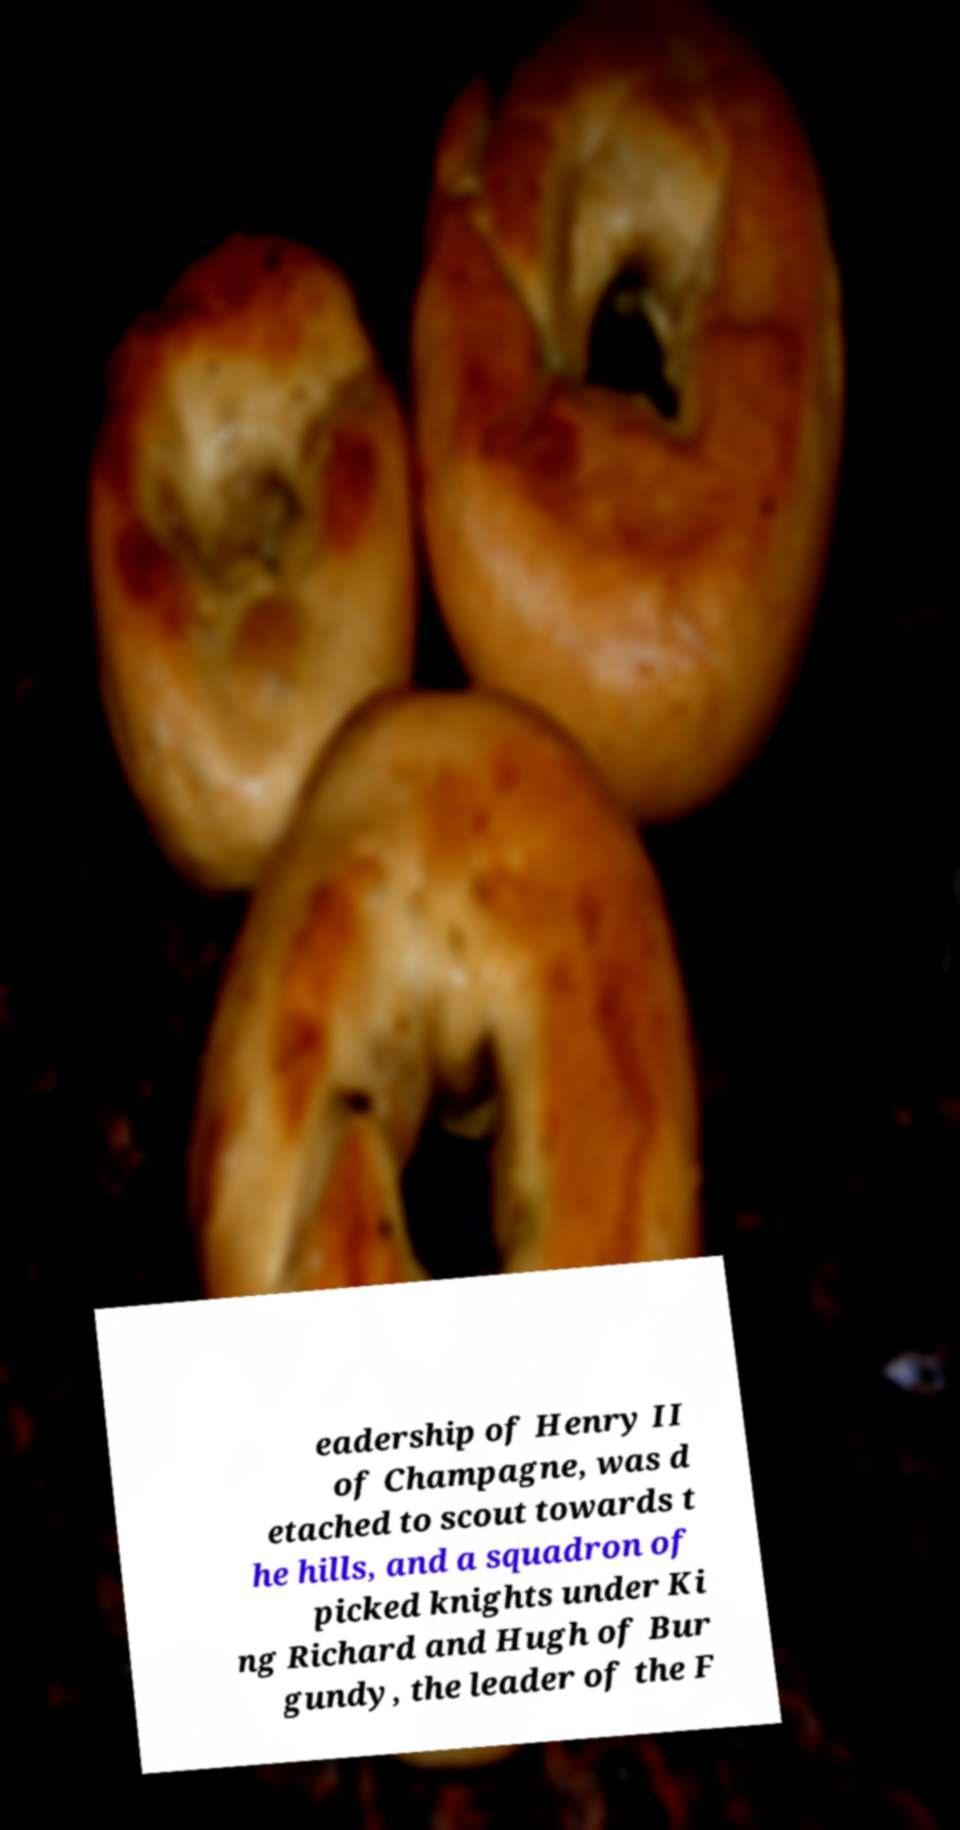Can you accurately transcribe the text from the provided image for me? eadership of Henry II of Champagne, was d etached to scout towards t he hills, and a squadron of picked knights under Ki ng Richard and Hugh of Bur gundy, the leader of the F 